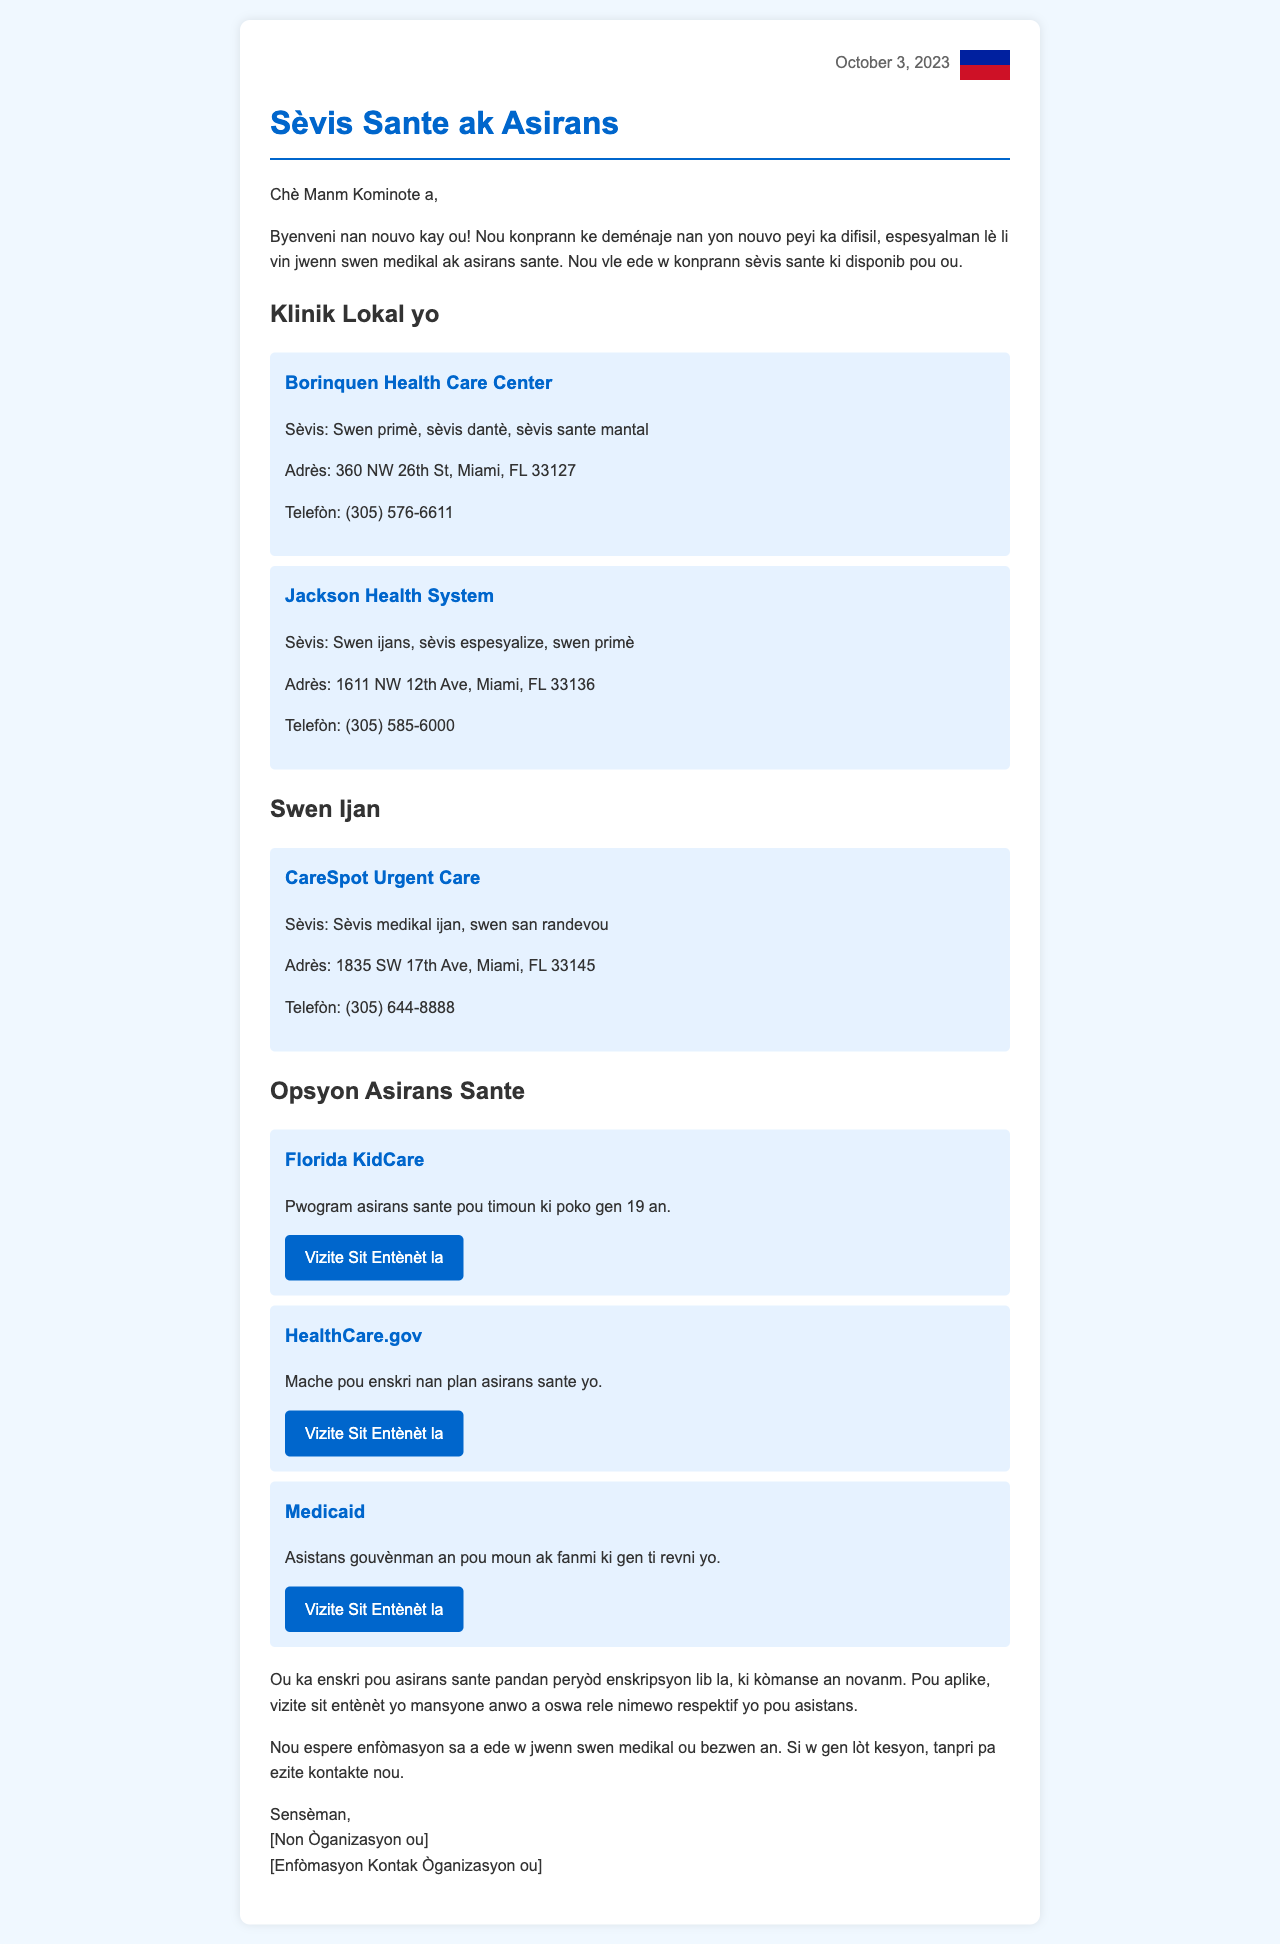What is the date of the letter? The letter is dated October 3, 2023.
Answer: October 3, 2023 What is the name of the first clinic listed? The first clinic mentioned in the document is Borinquen Health Care Center.
Answer: Borinquen Health Care Center What services does Jackson Health System provide? Jackson Health System provides emergency services, specialized services, and primary care.
Answer: Swen ijans, sèvis espesyalize, swen primè What is the website for Florida KidCare? Florida KidCare's website is provided in the letter for more information.
Answer: https://www.floridakidcare.org/ During which month does the open enrollment period start? The open enrollment period for insurance is stated to start in November.
Answer: Novanm What type of assistance does Medicaid provide? Medicaid provides assistance for individuals and families with low income.
Answer: Asistans gouvènman an pou moun ak fanmi ki gen ti revni yo What service does CareSpot Urgent Care offer? CareSpot Urgent Care offers urgent medical services without an appointment.
Answer: Sèvis medikal ijan, swen san randevou Who is the letter addressed to? The letter is addressed to members of the community.
Answer: Manm Kominote a 